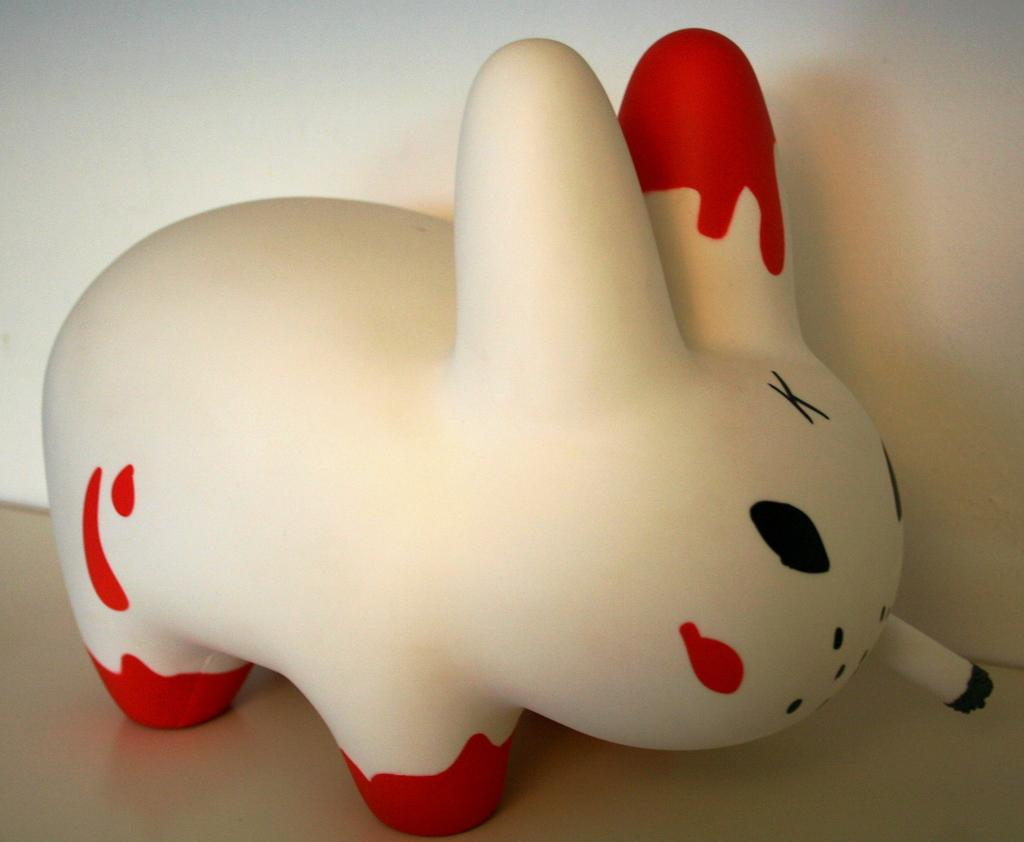What is the main subject of the image? The main subject of the image is a doll. Can you describe the colors of the doll? The doll is in white and red color. What is the plot of the story involving the doll and a hammer in the image? There is no story or plot depicted in the image, nor is there a hammer present. 